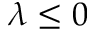Convert formula to latex. <formula><loc_0><loc_0><loc_500><loc_500>\lambda \leq 0</formula> 